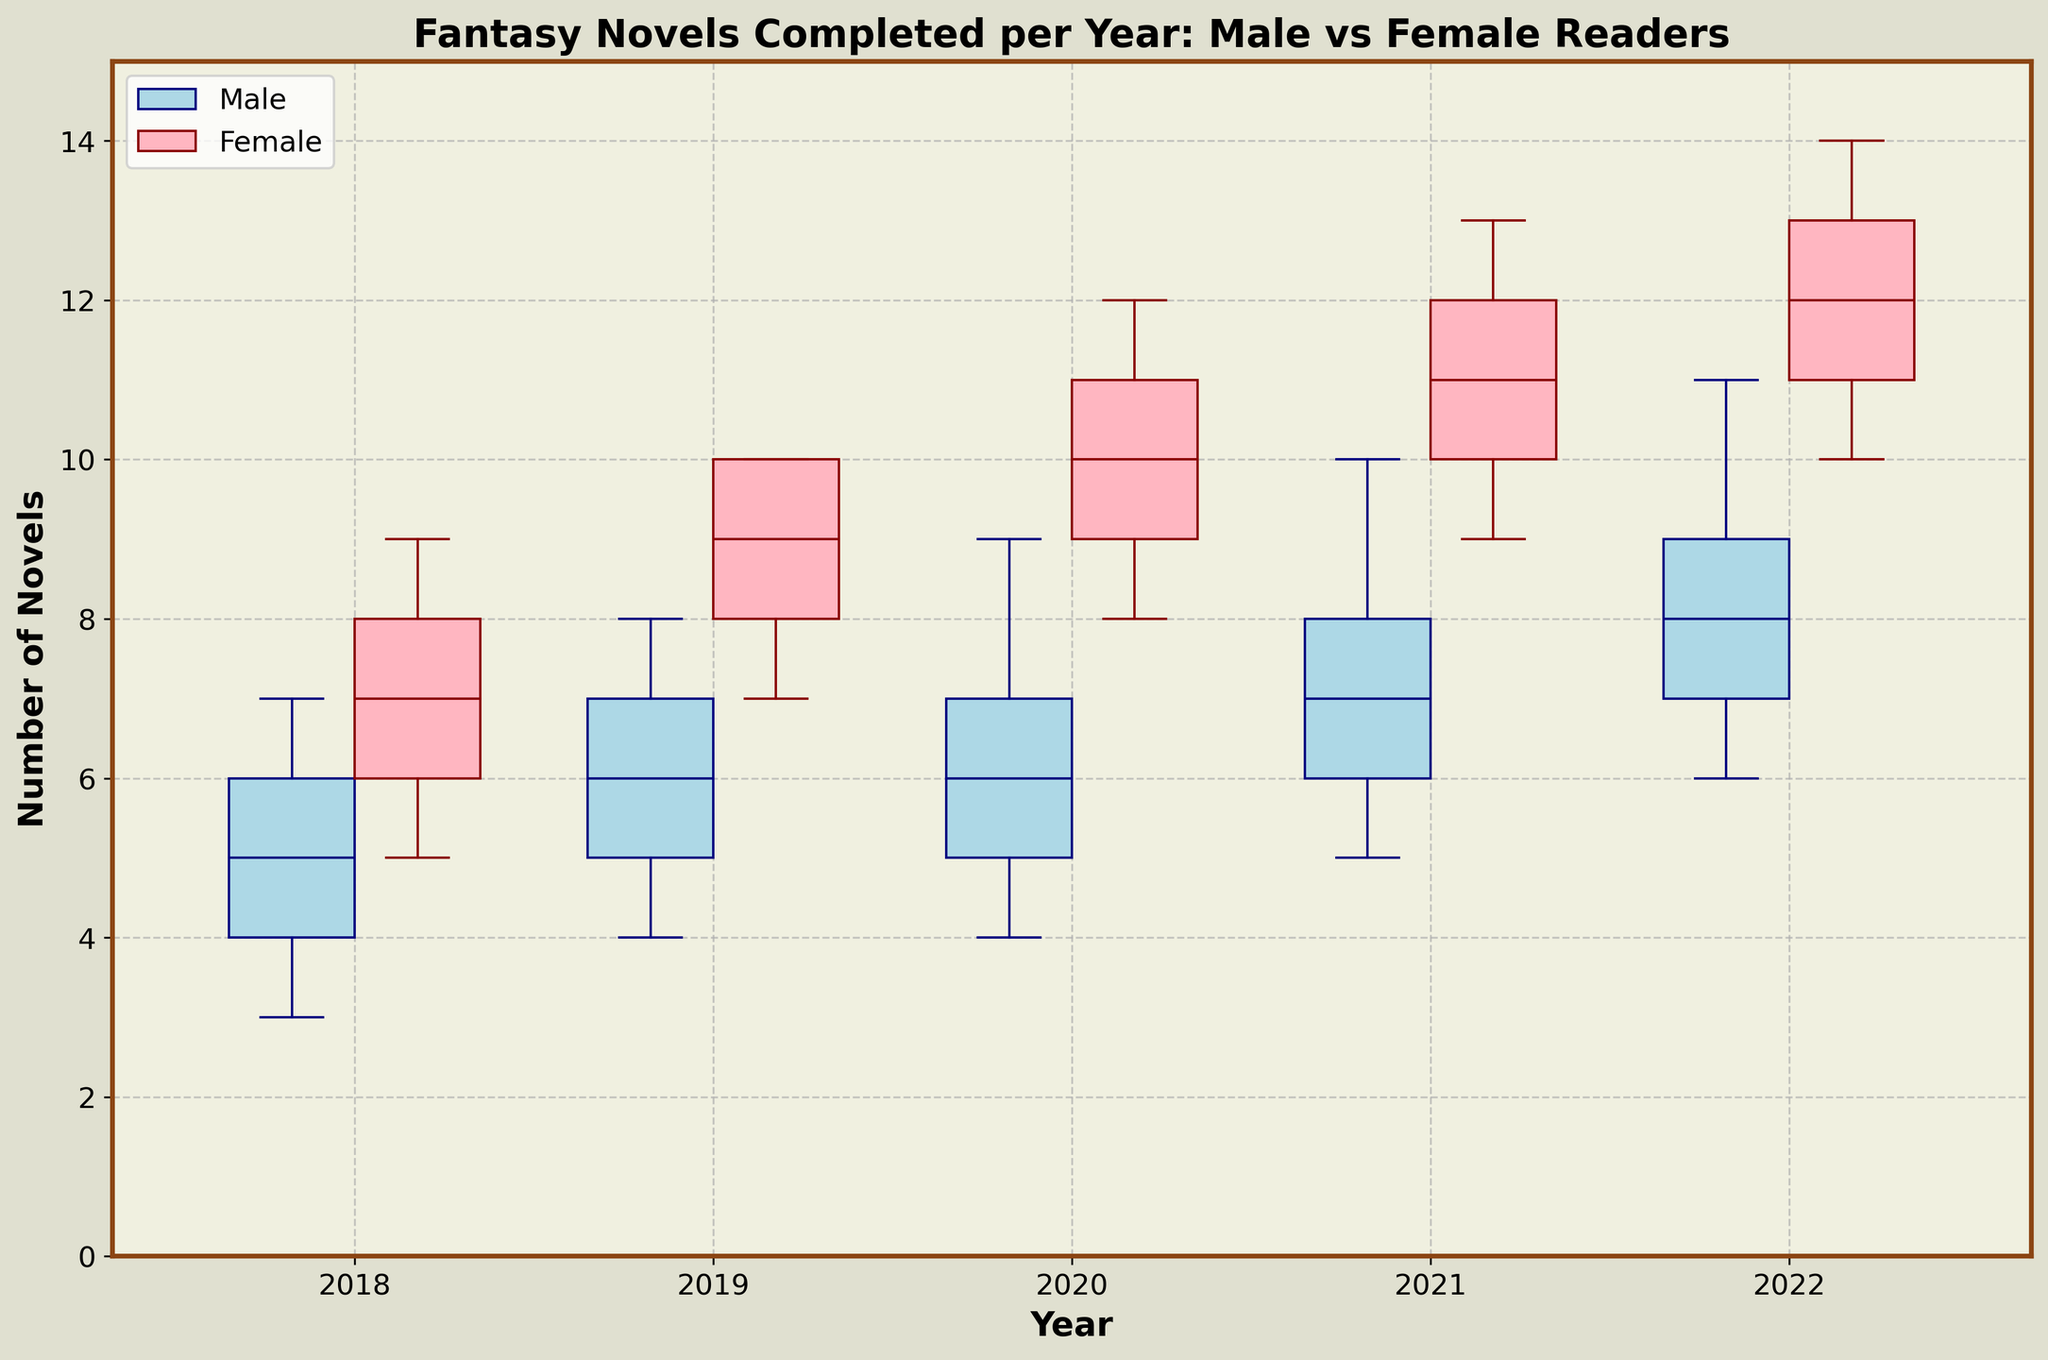What is the title of the plot? The title is usually located at the top center of the plot. You can see the phrase "Fantasy Novels Completed per Year: Male vs Female Readers" displayed clearly.
Answer: Fantasy Novels Completed per Year: Male vs Female Readers What are the colors used for the boxes representing male and female readers? The boxes for male readers are filled with light blue and outlined in navy, while the boxes for female readers are filled with light pink and outlined in dark red.
Answer: Light blue and light pink What is the median number of novels completed by male readers in 2018? Locate the male box for the year 2018. The median is indicated by the line inside the box. From the plot, the median is at 5.
Answer: 5 Which year shows the highest median number of novels completed by female readers? Look at the line inside the boxes representing female readers for each year. The highest median line is in 2022.
Answer: 2022 Is there any year where the interquartile range (IQR) for male readers is larger than for female readers? The IQR is represented by the height of the boxes. For each year, compare the male and female boxes' heights. There is no year where the IQR for male readers is larger.
Answer: No Compare the median number of novels completed by male and female readers in 2019. Locate the medians for both male and female readers for 2019. The male median is at 6, and the female median is at 9.
Answer: Male: 6, Female: 9 What is the range of the number of novels completed by female readers in 2021? Range is calculated by subtracting the smallest value represented by the lower whisker from the largest value represented by the upper whisker. In 2021 for female readers, the range is 13 - 9 = 4.
Answer: 4 Between which two years did the median number of novels completed by male readers increase the most? Check the median lines for male readers from year to year. The largest increase in the median occurs between 2020 (median 6) and 2021 (median 7), an increase of 1.
Answer: 2020 and 2021 How do the maximum values of the number of novels completed compare between male readers in 2020 and female readers in 2020? The maximum value is indicated by the top whisker. For male readers in 2020 the maximum is 9, and for female readers, it is 12.
Answer: Male: 9, Female: 12 What is the trend in the median number of novels completed by female readers from 2018 to 2022? Observe the median lines for female readers over the years 2018 to 2022. The medians are consistently increasing: 7 in 2018, 9 in 2019, 10 in 2020, 11 in 2021, and 12 in 2022.
Answer: Increasing trend 